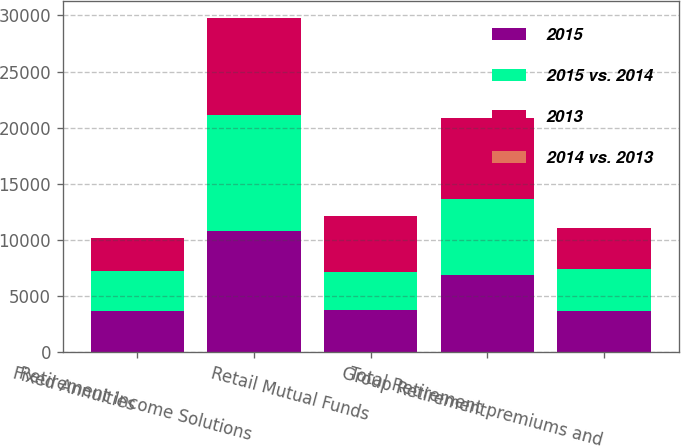Convert chart. <chart><loc_0><loc_0><loc_500><loc_500><stacked_bar_chart><ecel><fcel>Fixed Annuities<fcel>Retirement Income Solutions<fcel>Retail Mutual Funds<fcel>Group Retirement<fcel>Total Retirement premiums and<nl><fcel>2015<fcel>3702<fcel>10828<fcel>3791<fcel>6920<fcel>3702<nl><fcel>2015 vs. 2014<fcel>3578<fcel>10325<fcel>3377<fcel>6743<fcel>3702<nl><fcel>2013<fcel>2914<fcel>8608<fcel>4956<fcel>7251<fcel>3702<nl><fcel>2014 vs. 2013<fcel>3<fcel>5<fcel>12<fcel>3<fcel>5<nl></chart> 